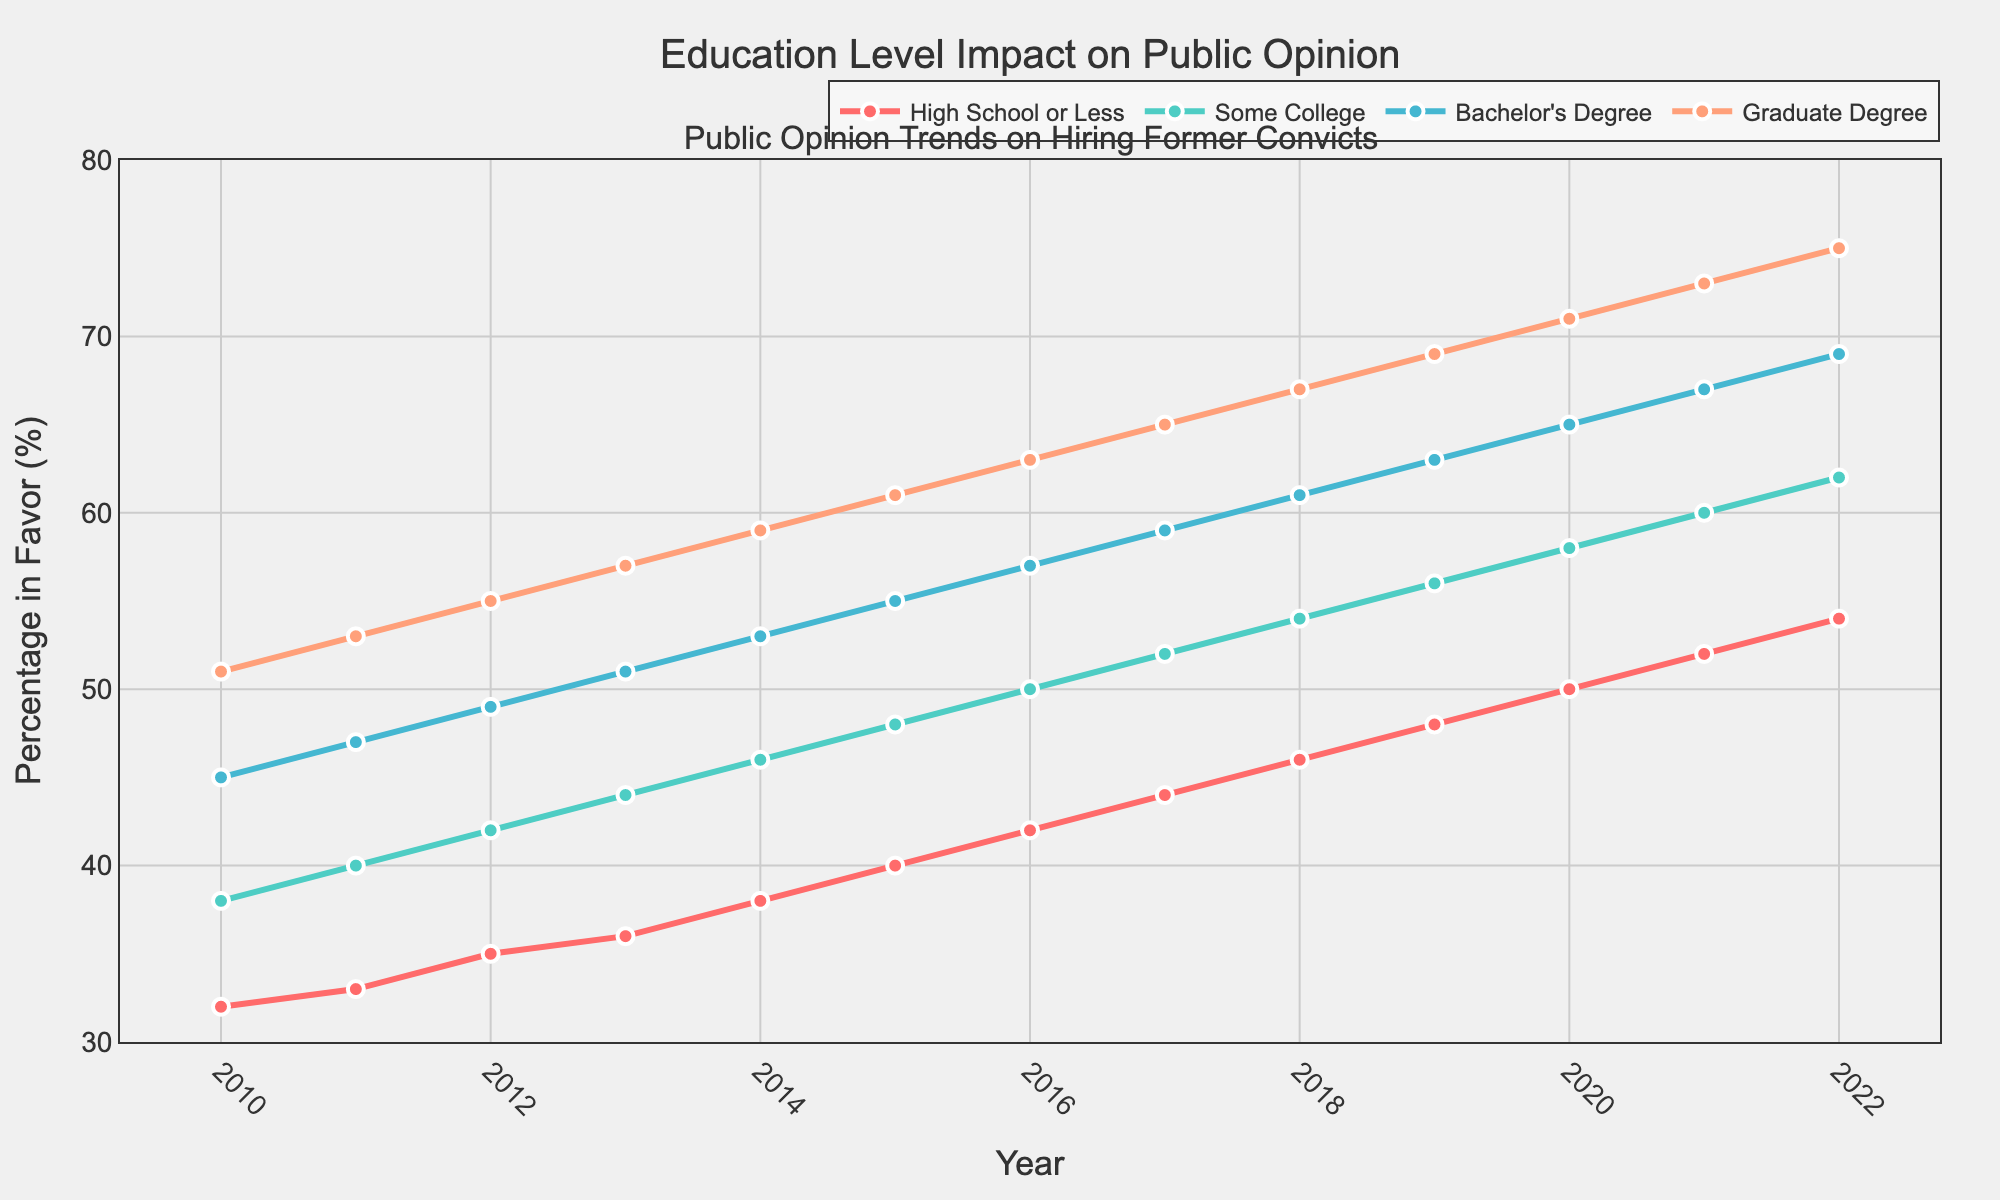What year did public opinion among those with a Bachelor's Degree first reach 65% in favor of hiring former convicts? To find the first year the Bachelor's Degree percentage reached 65%, look at the data for the "Bachelor's Degree" and identify the year when it first reached 65%. This occurred in 2020.
Answer: 2020 In 2013, which education level had the highest percentage in favor of hiring former convicts? Look at the percentages for each education level in 2013. The Graduate Degree category had the highest percentage at 57%.
Answer: Graduate Degree By what percentage did the opinion of those with Some College education increase from 2011 to 2021? Calculate the difference between the 2021 and 2011 percentages for "Some College": 60 - 40 = 20%.
Answer: 20% Compare the trend lines for High School or Less and Graduate Degree from 2010 to 2022. Which education category had a steeper increase in favorability percentage? The High School or Less category increased from 32% to 54%, a gain of 22 percentage points. The Graduate Degree category increased from 51% to 75%, a gain of 24 percentage points. The Graduate Degree had a steeper increase.
Answer: Graduate Degree Calculate the average annual increase in favorability for Bachelor's Degree holders from 2010 to 2022. The difference in percentages from 2010 to 2022 for the Bachelor's Degree group is 69 - 45 = 24. There are 12 years between 2010 and 2022. The average annual increase is 24 / 12 = 2%.
Answer: 2% Which education category showed the least variability in favorability trends over the years? To find the least variability, look at the overall changes from 2010 to 2022 for each category. The High School or Less category shows the smallest total change (54 - 32 = 22%).
Answer: High School or Less In what year did all education levels show a favorability percentage above 50%? Locate the year when each education level had a percentage above 50%. All education levels crossed the 50% mark in 2016.
Answer: 2016 Which education level showed the most consistent (linear) increase in percentage over the years? To determine this, evaluate the trend lines for each education level. The Bachelor's Degree category shows a very consistent, steady increase from 2010 to 2022.
Answer: Bachelor's Degree In 2022, which education level's opinion was closest to the overall average percentage across all education levels? First, find the average percentage for 2022: (54 + 62 + 69 + 75) / 4 = 65%. The Bachelor's Degree category with 69% is the closest to the average percentage.
Answer: Bachelor's Degree 